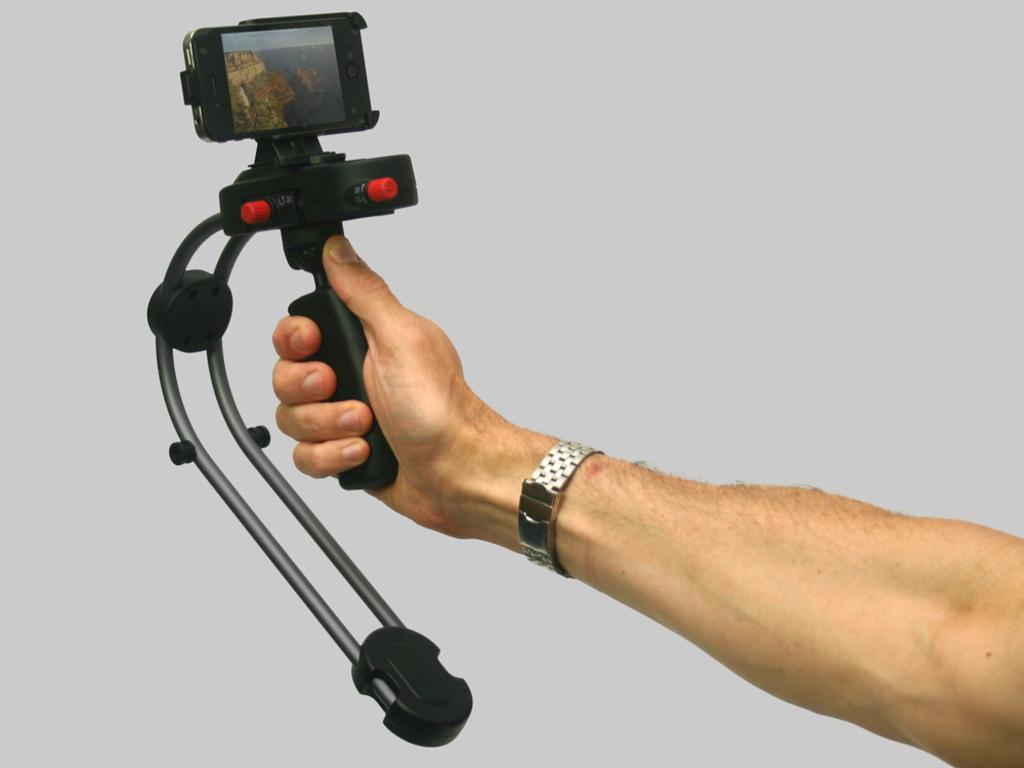What can be seen in the image that belongs to a person? There is a person's hand in the image. What is the person's hand holding? The hand is holding a black object. What other electronic device is visible in the image? There is a cellphone in the image. How are the black object and the cellphone related in the image? The cellphone is touching the black object. What accessory is on the person's hand? There is a watch on the person's hand. What color is the background of the image? The background of the image is white. What type of bait is being used to catch fish in the image? There is no fishing or bait present in the image; it features a person's hand holding a black object and a cellphone. What flavor of cream can be seen on the person's hand in the image? There is no cream present on the person's hand in the image; it features a watch and a black object being held by the hand. 